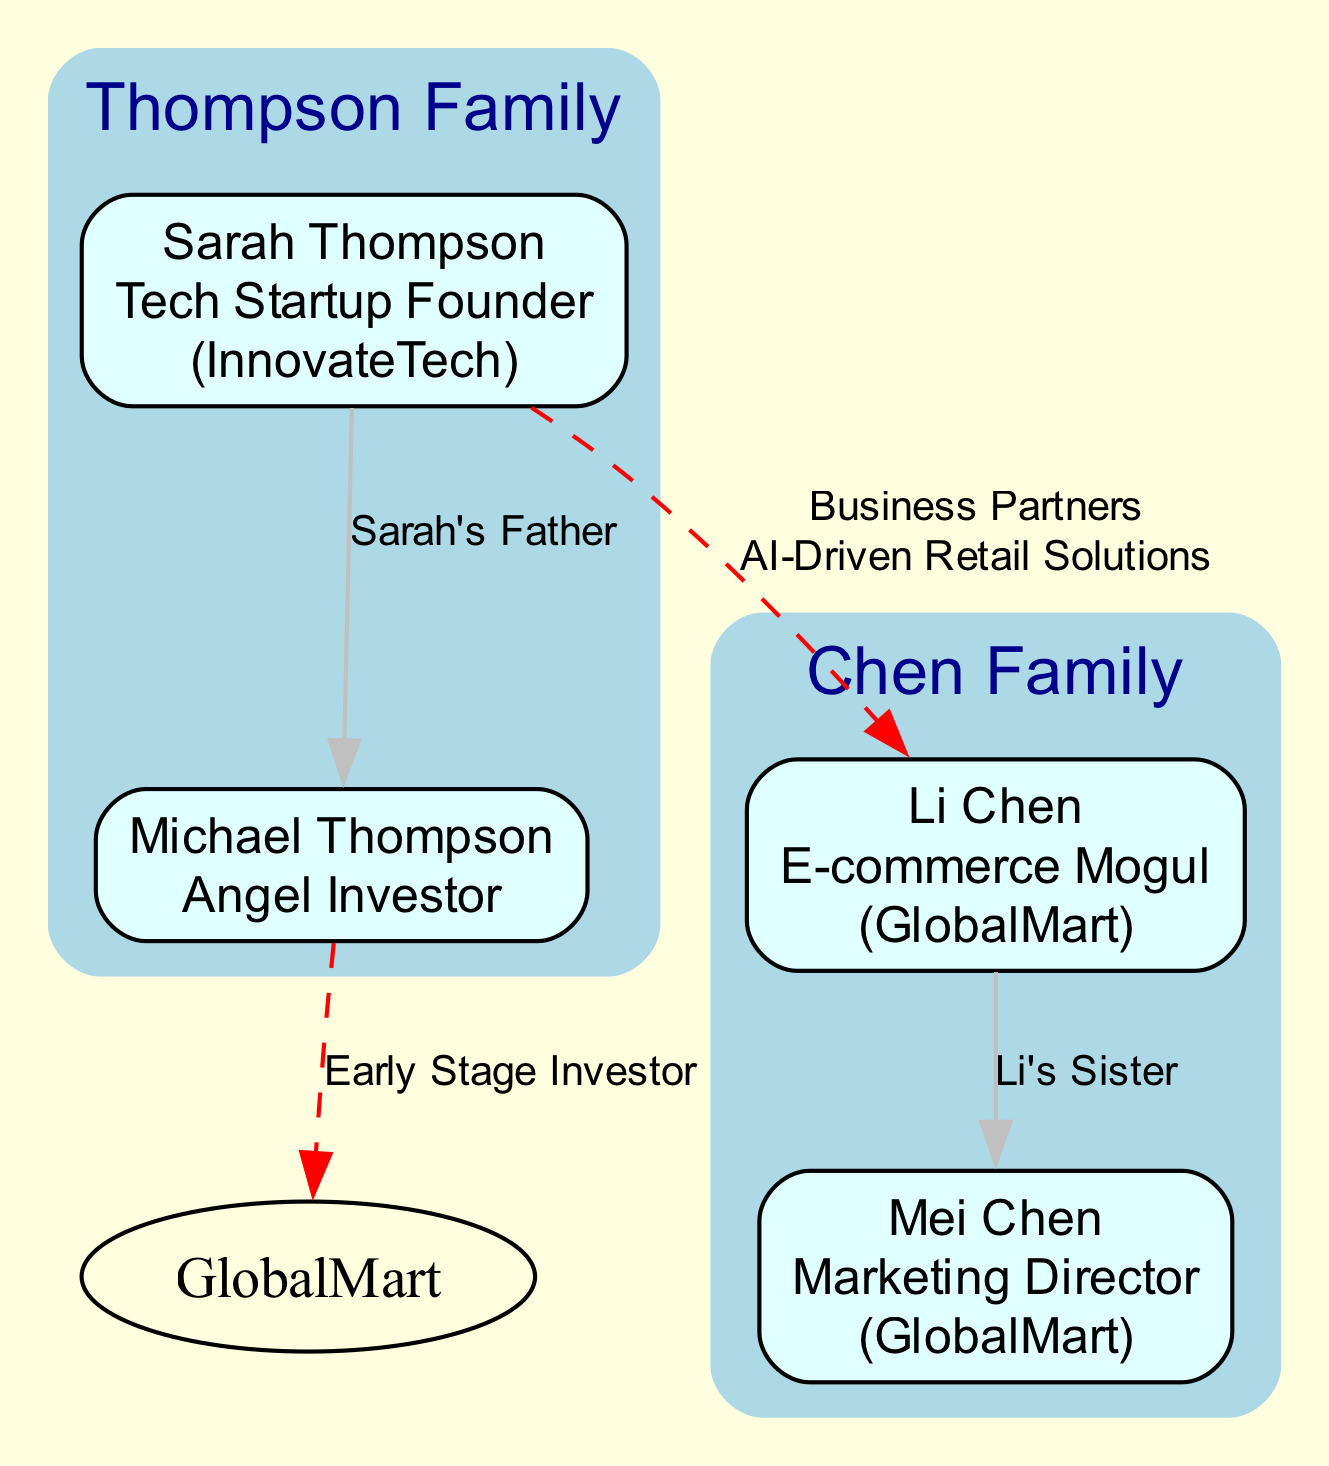What is the name of Sarah Thompson's company? According to the diagram, Sarah Thompson is identified as the Tech Startup Founder and her associated company is InnovateTech.
Answer: InnovateTech Who is Li Chen's sister? From the family tree, Mei Chen is listed as Li Chen's sister, as indicated by her relation status in the members section of the Chen Family.
Answer: Mei Chen How many members are there in the Thompson Family? The Thompson Family consists of two members: Sarah Thompson and Michael Thompson, which can be counted from the members listed under the Thompson Family in the diagram.
Answer: 2 What type of relationship do Sarah Thompson and Li Chen have? The relationship between Sarah Thompson and Li Chen is defined as Business Partners, shown by the connection linking them in the diagram with that specific label.
Answer: Business Partners Who is the Angel Investor in the diagram? The diagram shows that Michael Thompson holds the role of Angel Investor, as his title is clearly stated in his member information within the Thompson Family.
Answer: Michael Thompson How many companies are mentioned in the document? The diagram mentions two companies: InnovateTech and GlobalMart, associated with Sarah Thompson and Li Chen respectively, making it easy to identify them in the members sections of the families.
Answer: 2 What is the venture between Sarah Thompson and Li Chen? The venture shared by Sarah Thompson and Li Chen is labeled as AI-Driven Retail Solutions, as stated in the connection that defines their productive partnership in the diagram.
Answer: AI-Driven Retail Solutions Who invested in GlobalMart during its early stages? Michael Thompson is noted as the Early Stage Investor in GlobalMart, indicated by the connection showing his relationship to the company within the diagram.
Answer: Michael Thompson What role does Mei Chen have in GlobalMart? According to the details in the diagram, Mei Chen serves as the Marketing Director for GlobalMart, as her role is clearly specified in the member information for the Chen Family.
Answer: Marketing Director 